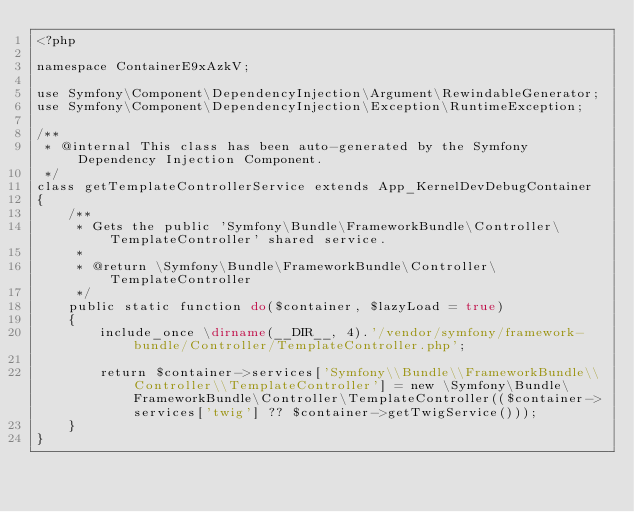Convert code to text. <code><loc_0><loc_0><loc_500><loc_500><_PHP_><?php

namespace ContainerE9xAzkV;

use Symfony\Component\DependencyInjection\Argument\RewindableGenerator;
use Symfony\Component\DependencyInjection\Exception\RuntimeException;

/**
 * @internal This class has been auto-generated by the Symfony Dependency Injection Component.
 */
class getTemplateControllerService extends App_KernelDevDebugContainer
{
    /**
     * Gets the public 'Symfony\Bundle\FrameworkBundle\Controller\TemplateController' shared service.
     *
     * @return \Symfony\Bundle\FrameworkBundle\Controller\TemplateController
     */
    public static function do($container, $lazyLoad = true)
    {
        include_once \dirname(__DIR__, 4).'/vendor/symfony/framework-bundle/Controller/TemplateController.php';

        return $container->services['Symfony\\Bundle\\FrameworkBundle\\Controller\\TemplateController'] = new \Symfony\Bundle\FrameworkBundle\Controller\TemplateController(($container->services['twig'] ?? $container->getTwigService()));
    }
}
</code> 